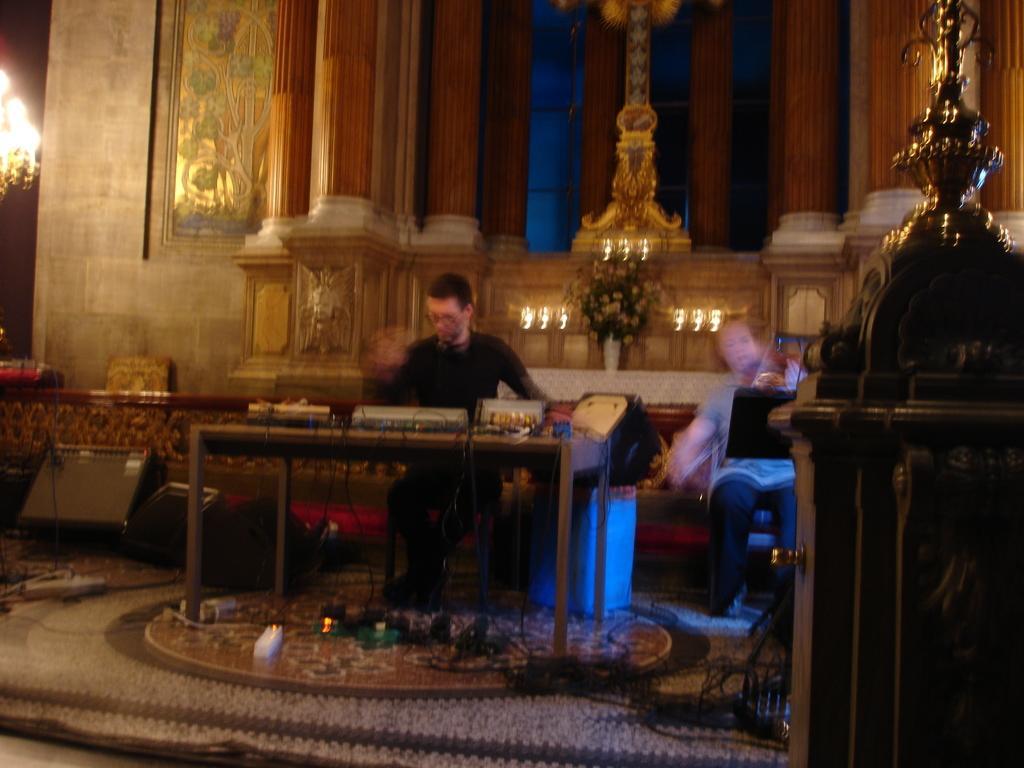Describe this image in one or two sentences. In this picture we can see two persons are sitting, we can see a table in the middle, we can see some things placed on the table, at the bottom we can see some wires and a switchboard, it looks like a chandelier at the left top of the picture, there is a blurry background. 